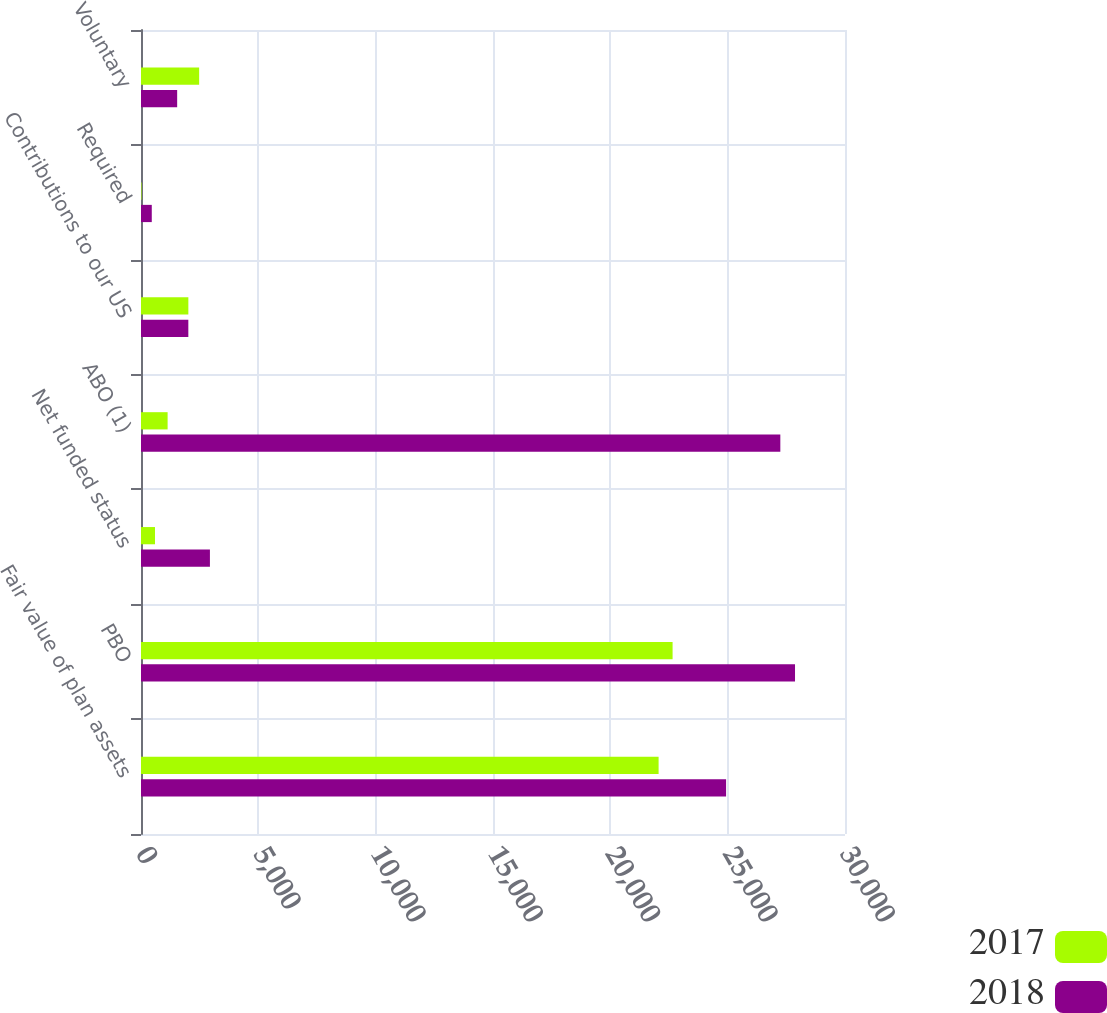<chart> <loc_0><loc_0><loc_500><loc_500><stacked_bar_chart><ecel><fcel>Fair value of plan assets<fcel>PBO<fcel>Net funded status<fcel>ABO (1)<fcel>Contributions to our US<fcel>Required<fcel>Voluntary<nl><fcel>2017<fcel>22057<fcel>22653<fcel>596<fcel>1134<fcel>2018<fcel>22<fcel>2478<nl><fcel>2018<fcel>24933<fcel>27870<fcel>2937<fcel>27244<fcel>2017<fcel>459<fcel>1541<nl></chart> 